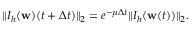Convert formula to latex. <formula><loc_0><loc_0><loc_500><loc_500>\begin{array} { r } { \| I _ { h } ( w ) ( t + \Delta t ) \| _ { 2 } = e ^ { - \mu \Delta t } \| I _ { h } ( w ( t ) ) \| _ { 2 } . } \end{array}</formula> 